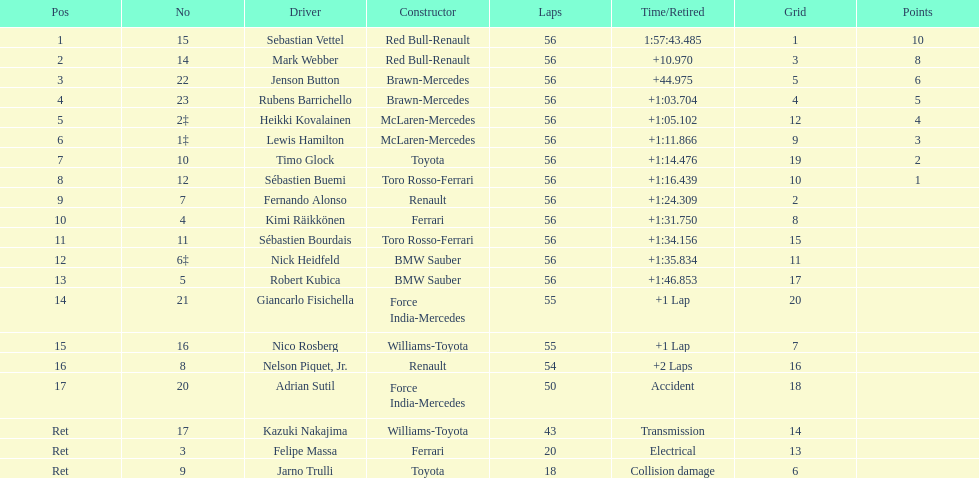What is the overall count of laps in the race? 56. 